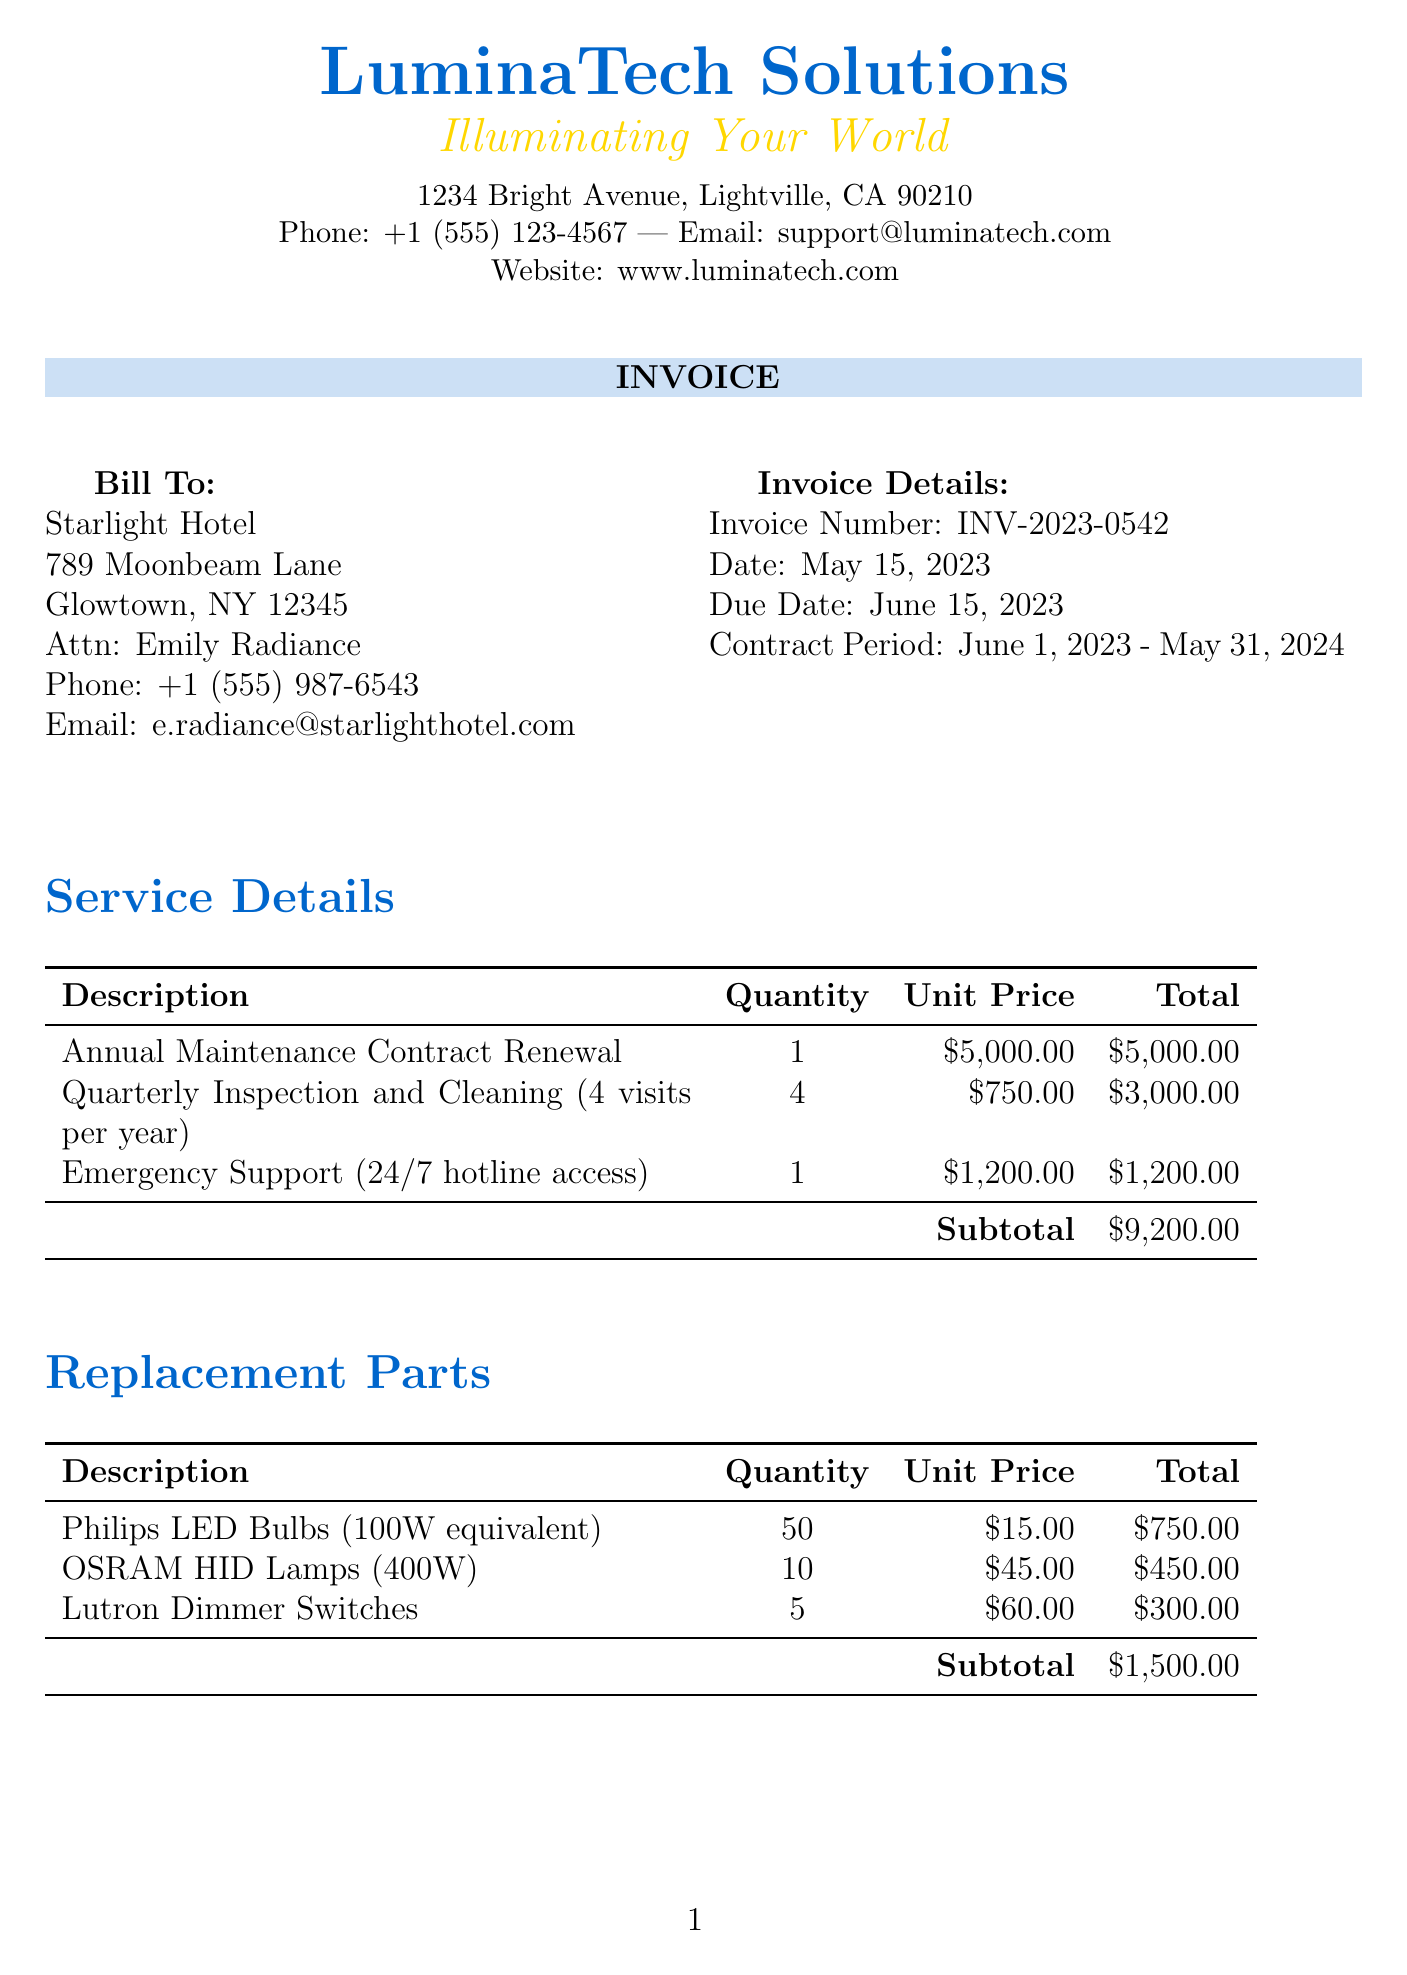What is the invoice number? The invoice number can be found in the invoice details section, which states it as INV-2023-0542.
Answer: INV-2023-0542 What is the contract period? The contract period is stated in the invoice details section and is from June 1, 2023, to May 31, 2024.
Answer: June 1, 2023 - May 31, 2024 How many quarterly inspections are included in the contract? The service details list that there are 4 visits for quarterly inspection and cleaning.
Answer: 4 What is the total due amount on the invoice? The total due is highlighted at the bottom of the invoice, which totals $10,700.00.
Answer: $10,700.00 What is the unit price for the emergency call-out fee? The unit price for the emergency call-out fee is listed in the additional services section as $250.00 per incident.
Answer: $250.00 How often are the quarterly inspections held? According to the notes, inspections are held quarterly in March, June, September, and December.
Answer: March, June, September, December What is the total for replacement parts? The subtotal for replacement parts is shown in the replacement parts table as $1,500.00.
Answer: $1,500.00 What is the main method of payment accepted? The payment terms state that the method accepted is bank transfer or check.
Answer: Bank transfer or check 